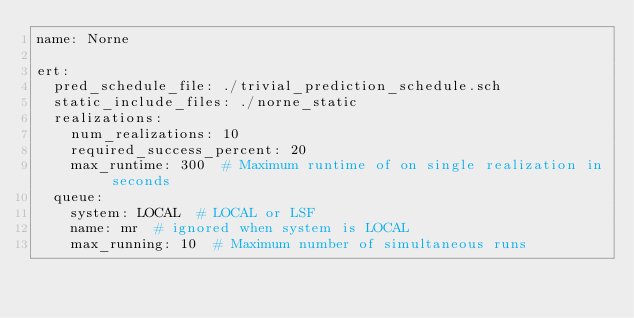<code> <loc_0><loc_0><loc_500><loc_500><_YAML_>name: Norne

ert:
  pred_schedule_file: ./trivial_prediction_schedule.sch
  static_include_files: ./norne_static
  realizations:
    num_realizations: 10
    required_success_percent: 20
    max_runtime: 300  # Maximum runtime of on single realization in seconds
  queue:
    system: LOCAL  # LOCAL or LSF
    name: mr  # ignored when system is LOCAL
    max_running: 10  # Maximum number of simultaneous runs
</code> 